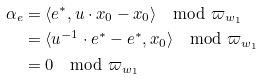Convert formula to latex. <formula><loc_0><loc_0><loc_500><loc_500>\alpha _ { e } & = \langle e ^ { * } , u \cdot x _ { 0 } - x _ { 0 } \rangle \mod \varpi _ { w _ { 1 } } \\ & = \langle u ^ { - 1 } \cdot e ^ { * } - e ^ { * } , x _ { 0 } \rangle \mod \varpi _ { w _ { 1 } } \\ & = 0 \mod \varpi _ { w _ { 1 } }</formula> 